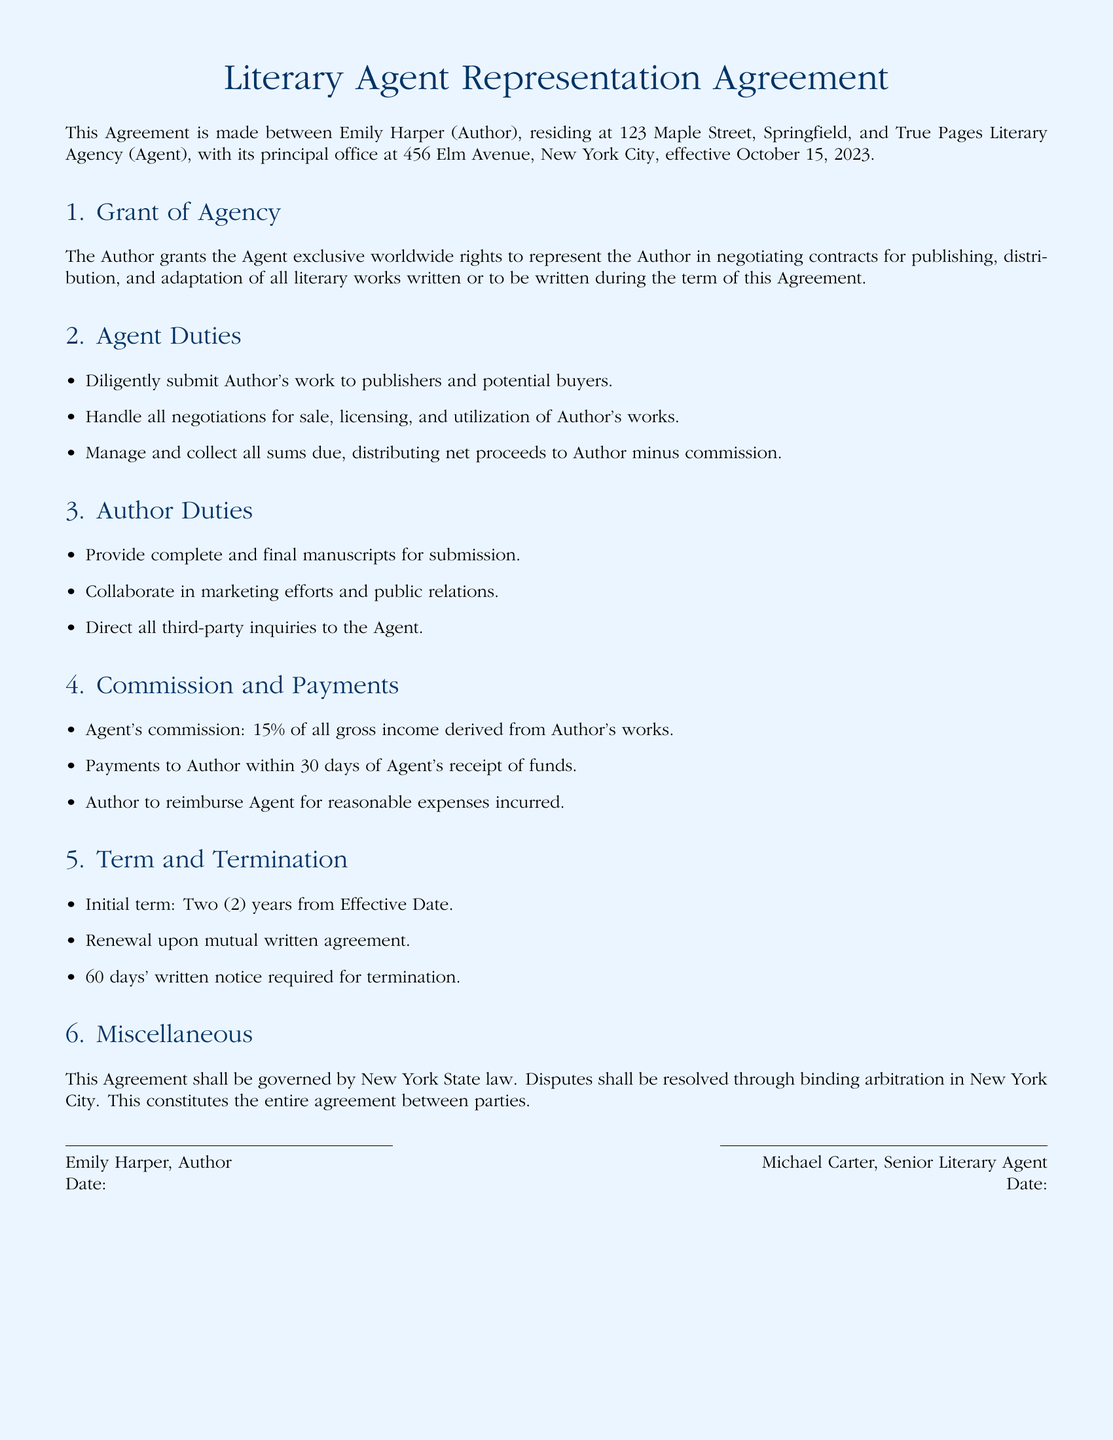What is the effective date of the agreement? The effective date is specified in the introductory paragraph of the document.
Answer: October 15, 2023 What is the author's name? The author's name is mentioned at the beginning of the agreement.
Answer: Emily Harper What is the agent's commission percentage? The agent's commission is detailed in the Commission and Payments section of the agreement.
Answer: 15% How long is the initial term of the agreement? The initial term duration is specified in the Term and Termination section.
Answer: Two (2) years Where will disputes be resolved? The location for dispute resolution is mentioned towards the end of the agreement.
Answer: New York City What are the agent's responsibilities? The responsibilities of the agent are outlined in the Agent Duties section.
Answer: Submit work, handle negotiations, manage collections What does the author need to provide? The Author Duties section specifies what the author must submit.
Answer: Complete and final manuscripts How much time is required for termination notice? The notice period for termination is mentioned in the Term and Termination section.
Answer: 60 days What law governs this agreement? The governing law is stated in the Miscellaneous section of the document.
Answer: New York State law 